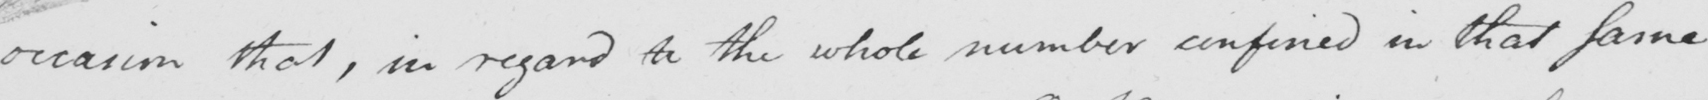Please provide the text content of this handwritten line. occasion that , in regard to the whole number confined in that same 